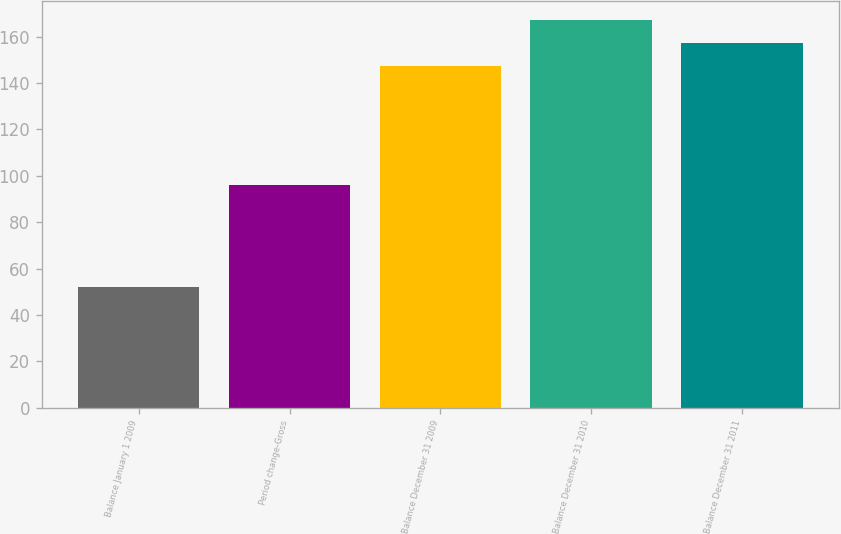<chart> <loc_0><loc_0><loc_500><loc_500><bar_chart><fcel>Balance January 1 2009<fcel>Period change-Gross<fcel>Balance December 31 2009<fcel>Balance December 31 2010<fcel>Balance December 31 2011<nl><fcel>52<fcel>96<fcel>147.2<fcel>167.02<fcel>157.11<nl></chart> 